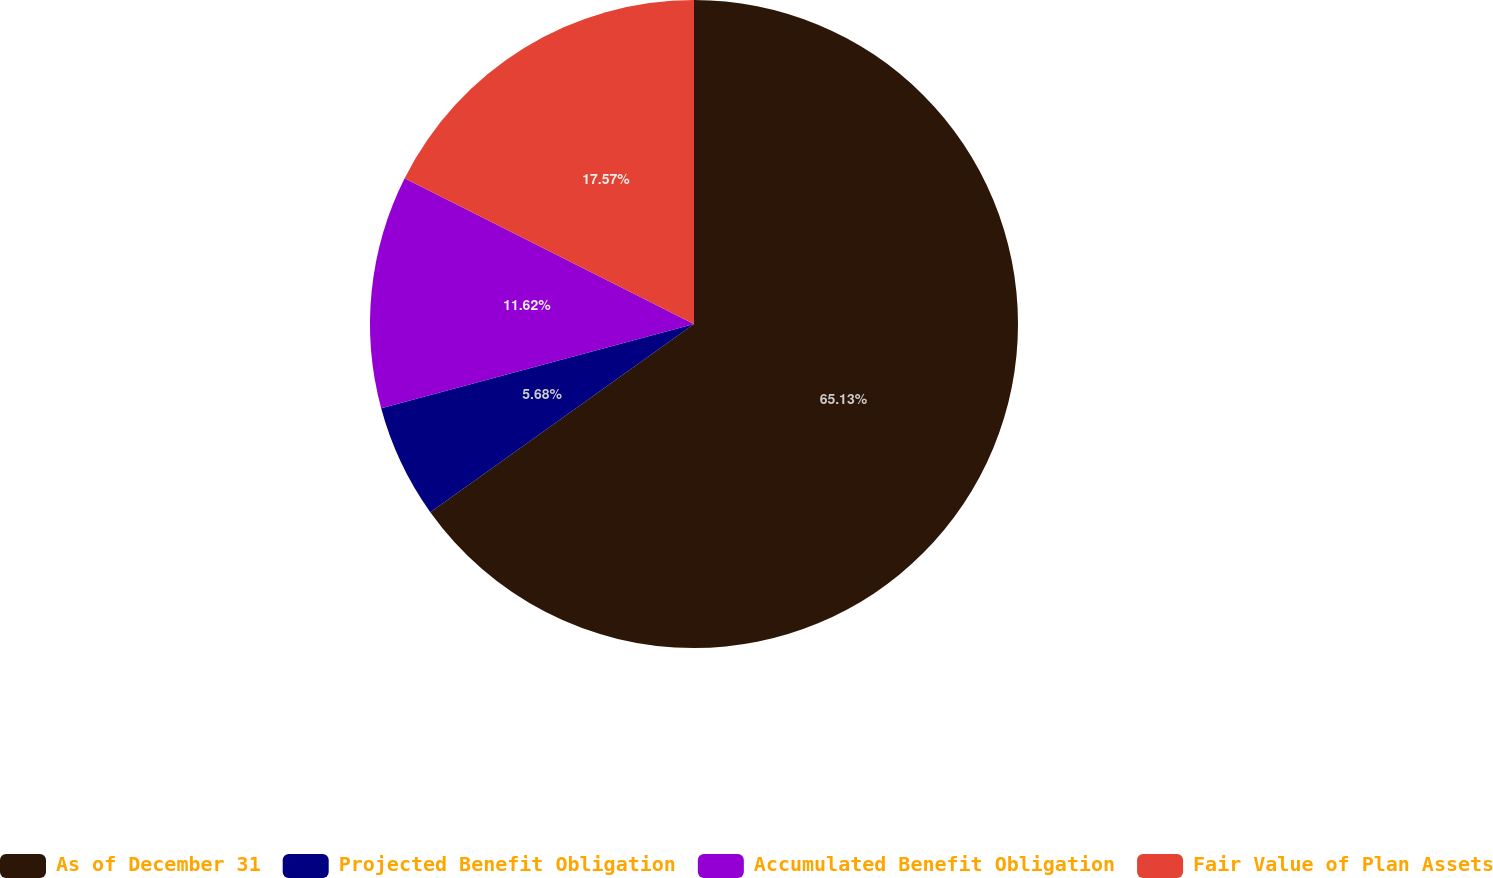Convert chart to OTSL. <chart><loc_0><loc_0><loc_500><loc_500><pie_chart><fcel>As of December 31<fcel>Projected Benefit Obligation<fcel>Accumulated Benefit Obligation<fcel>Fair Value of Plan Assets<nl><fcel>65.13%<fcel>5.68%<fcel>11.62%<fcel>17.57%<nl></chart> 